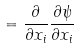Convert formula to latex. <formula><loc_0><loc_0><loc_500><loc_500>= \frac { \partial } { \partial x _ { i } } \frac { \partial \psi } { \partial x _ { i } }</formula> 